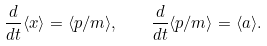Convert formula to latex. <formula><loc_0><loc_0><loc_500><loc_500>\frac { d } { d t } \langle { x } \rangle = \langle { p } / m \rangle , \quad \frac { d } { d t } \langle { p } / m \rangle = \langle { a } \rangle .</formula> 